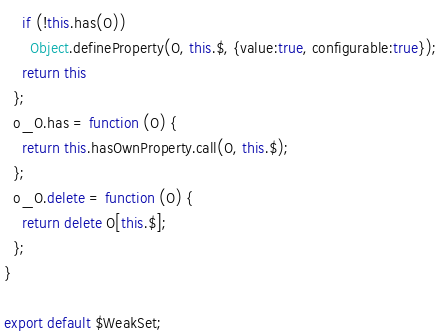<code> <loc_0><loc_0><loc_500><loc_500><_JavaScript_>    if (!this.has(O))
      Object.defineProperty(O, this.$, {value:true, configurable:true});
    return this
  };
  o_O.has = function (O) {
    return this.hasOwnProperty.call(O, this.$);
  };
  o_O.delete = function (O) {
    return delete O[this.$];
  };
}

export default $WeakSet;
</code> 